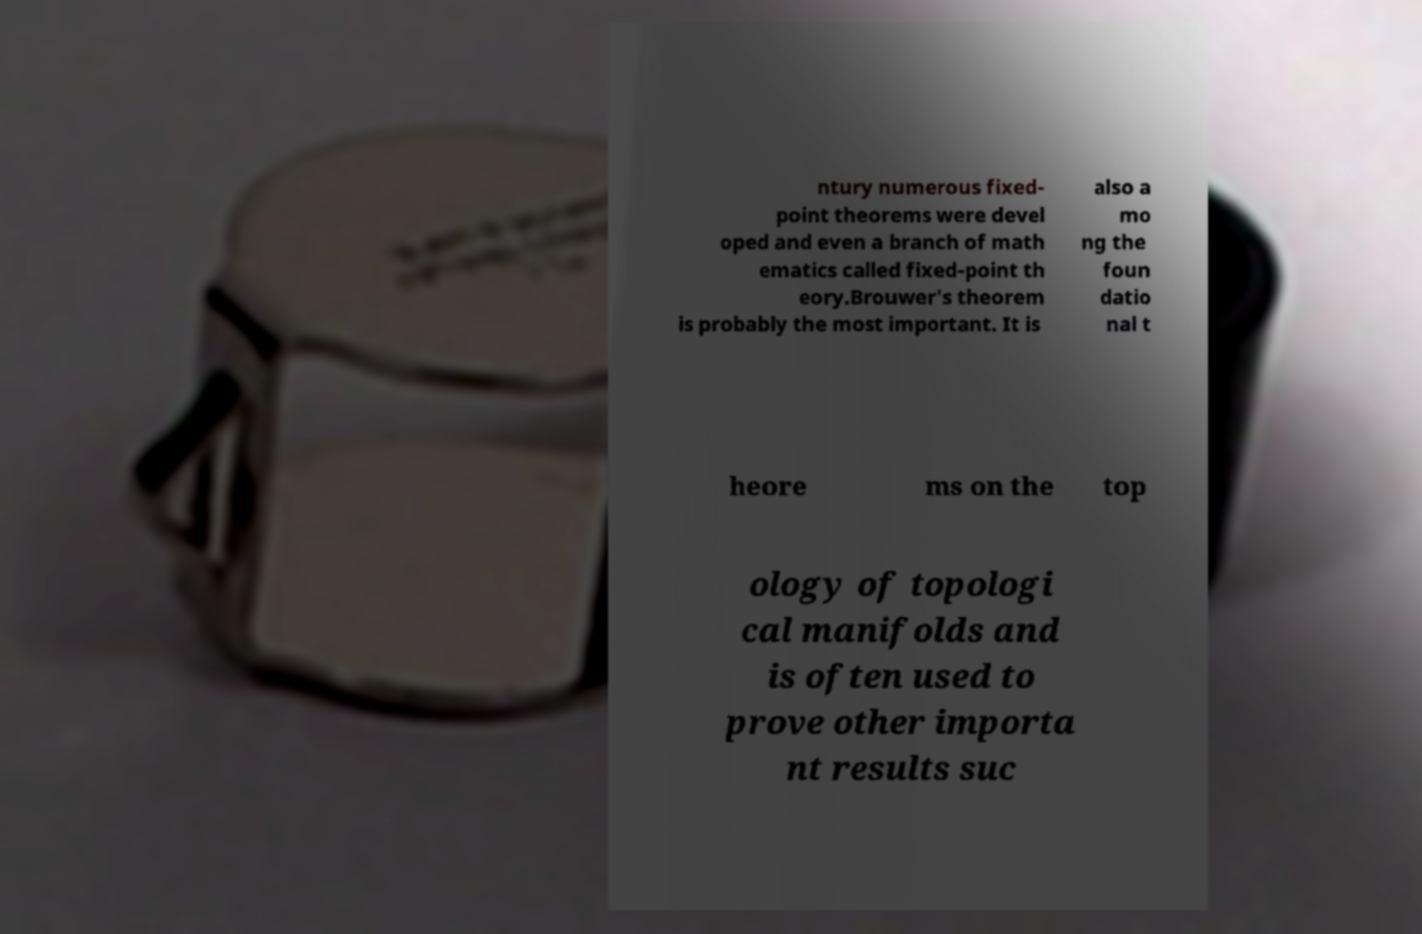Please identify and transcribe the text found in this image. ntury numerous fixed- point theorems were devel oped and even a branch of math ematics called fixed-point th eory.Brouwer's theorem is probably the most important. It is also a mo ng the foun datio nal t heore ms on the top ology of topologi cal manifolds and is often used to prove other importa nt results suc 